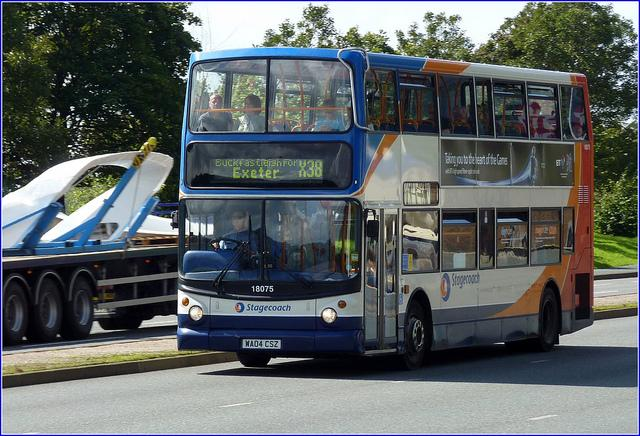In which country does this bus travel?

Choices:
A) usa
B) chile
C) england
D) canada england 